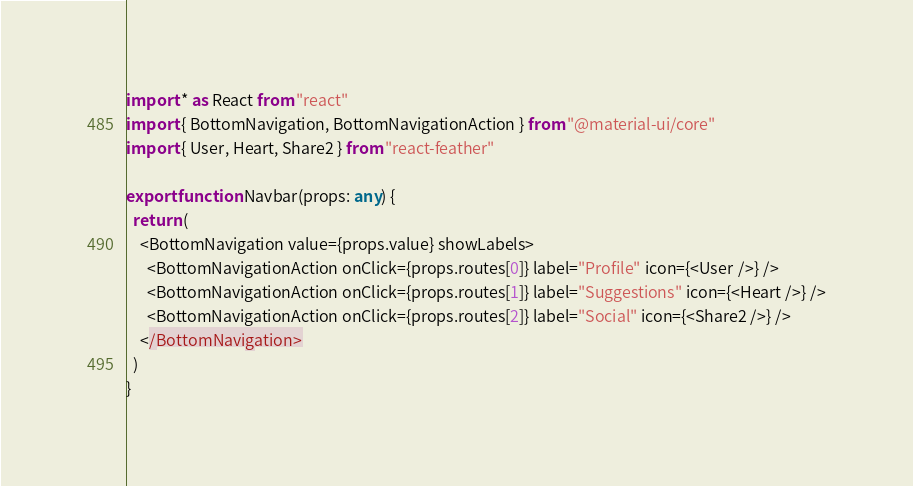Convert code to text. <code><loc_0><loc_0><loc_500><loc_500><_TypeScript_>import * as React from "react"
import { BottomNavigation, BottomNavigationAction } from "@material-ui/core"
import { User, Heart, Share2 } from "react-feather"

export function Navbar(props: any) {
  return (
    <BottomNavigation value={props.value} showLabels>
      <BottomNavigationAction onClick={props.routes[0]} label="Profile" icon={<User />} />
      <BottomNavigationAction onClick={props.routes[1]} label="Suggestions" icon={<Heart />} />
      <BottomNavigationAction onClick={props.routes[2]} label="Social" icon={<Share2 />} />
    </BottomNavigation>
  )
}
</code> 